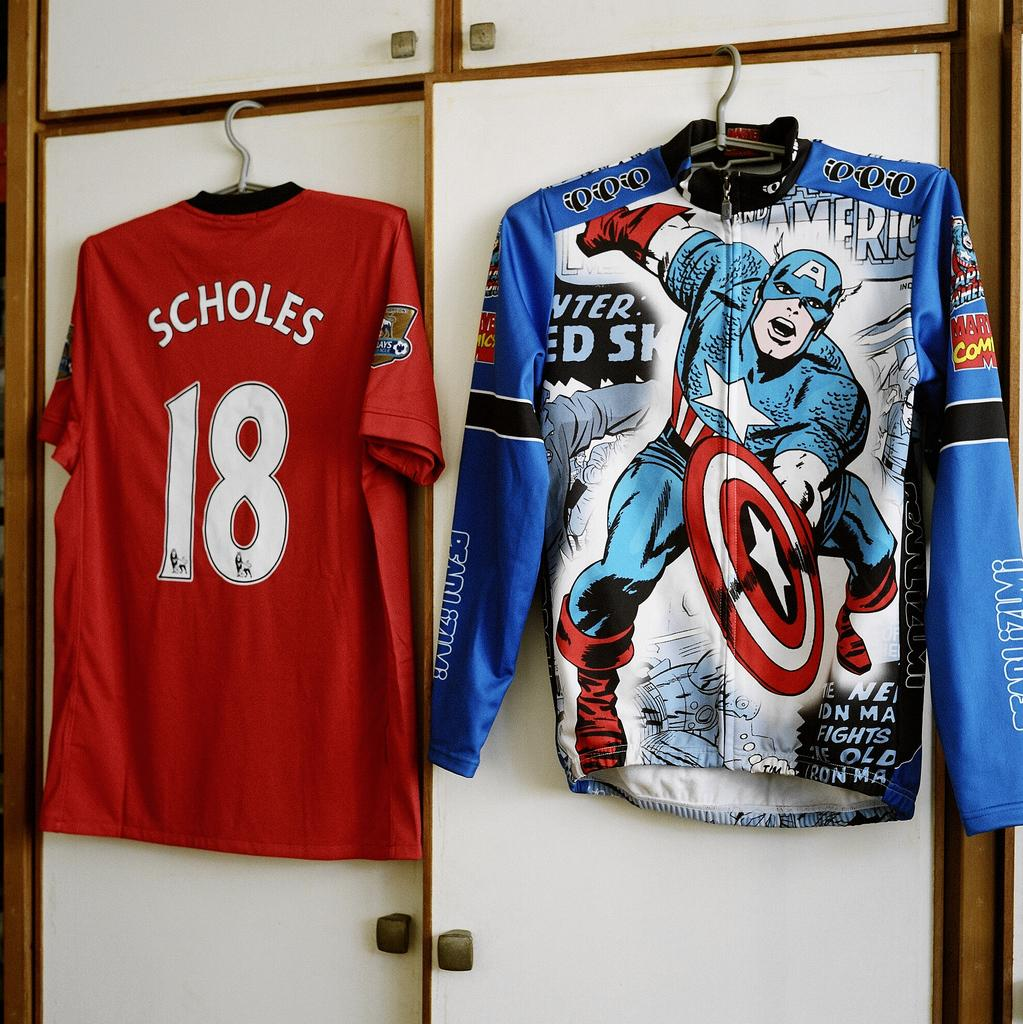What type of furniture is present in the image? There is a cupboard with two doors in the image. What is hanging on the cupboard? Two T-shirts are hanged on the cupboard. What colors are the T-shirts? One T-shirt is red in color, and the other is blue in color. What is depicted on the blue T-shirt? The blue T-shirt has cartoon paintings on it. Are there any spiders crawling on the red T-shirt in the image? There is no mention of spiders in the image, and therefore no such activity can be observed. 